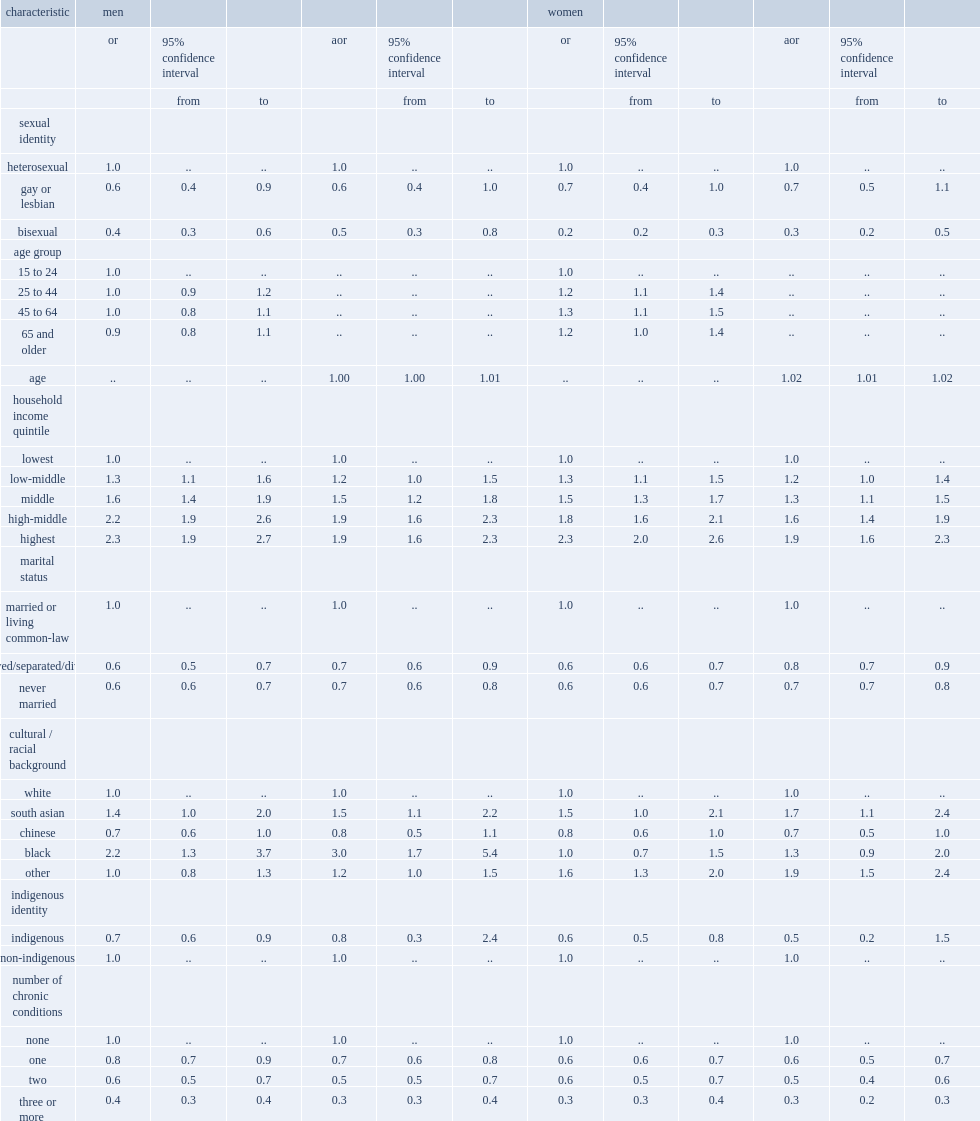Which kind of men have lower odds of complete mental health in the unadjusted models, bisexual men or heterosexual men? Bisexual. Which kind of men have lower odds of complete mental health in the fully adjusted models, bisexual men or heterosexual men? Bisexual. Which kind of women have lower odds of complete mental health in the unadjusted models, bisexual women or heterosexual women? Bisexual. Which kind of women have lower odds of complete mental health in the fully adjusted models, bisexual women or heterosexual women? Bisexual. Which marital status has the highest odds of complete mental health for men, widowed, separated, divorced, never married or married or in a common-law relationship? Married or living common-law. Which marital status has the highest odds of complete mental health for women, widowed, separated, divorced, never married or married or in a common-law relationship? Married or living common-law. Which cultural or racial background for men has higher odds of complete mental health, south asian or white? South asian. Which cultural or racial background for women has higher odds of complete mental health, south asian or white? South asian. Which cultural or racial background for men has higher odds of complete mental health, black or white? Black. Which cultural or racial background for women has higher odds of complete mental health, other or white? Other. Which identity is associated with lower odds of complete mental health in unadjusted models for men, indigenous or non-indigenous? Indigenous. 